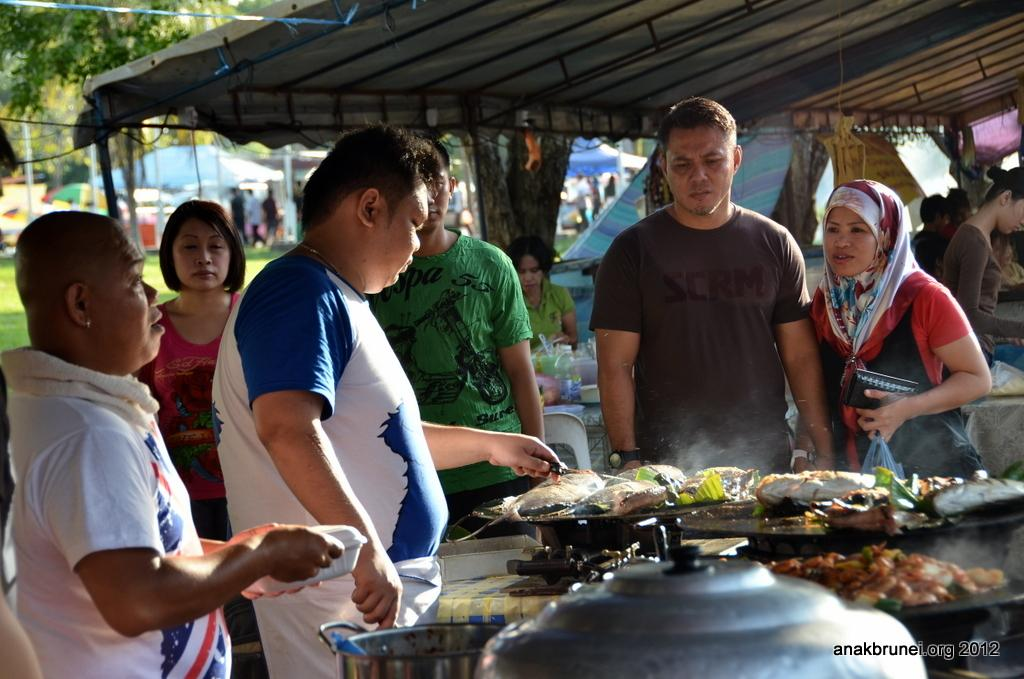Who or what can be seen in the image? There are people in the image. What is the source of heat or cooking in the image? There is a gas stove in the image. What type of temporary shelter is present in the image? There are tents in the image. What type of terrain is visible in the image? Grass is present in the image. What type of vegetation is visible in the image? There are trees in the image. What is being prepared or served in the image? There is a dish in the image. What type of force is being applied to the dish in the image? There is no force being applied to the dish in the image; it is stationary. What type of meal is being prepared or served in the image? The type of meal cannot be determined from the image, as only a dish is visible. Are there any fowls present in the image? There is no mention of fowls in the provided facts, and therefore no fowls are present in the image. 